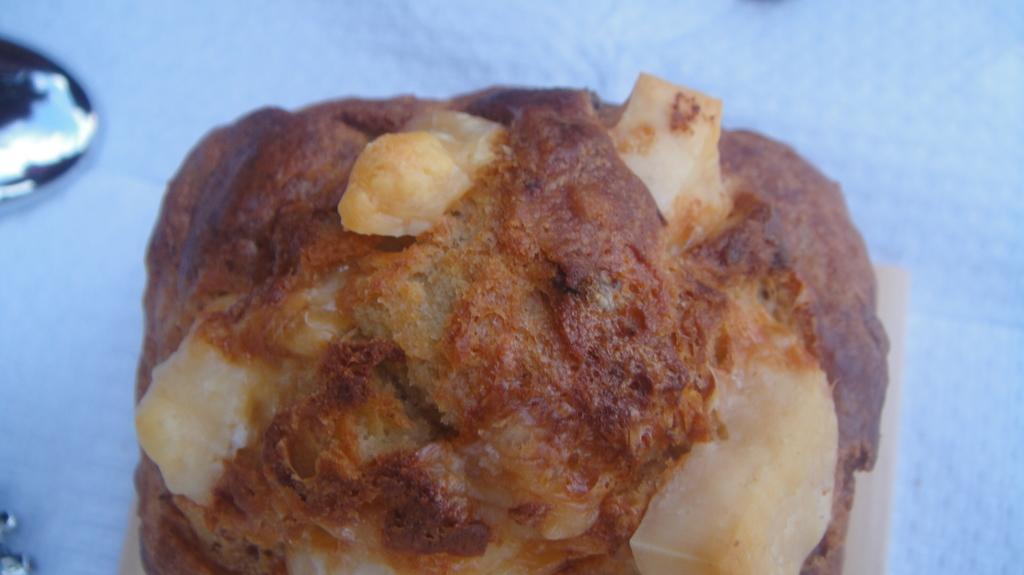In one or two sentences, can you explain what this image depicts? In this image there is a food item on the table beside that there is something. 